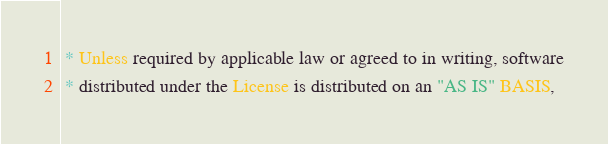<code> <loc_0><loc_0><loc_500><loc_500><_Scala_> * Unless required by applicable law or agreed to in writing, software
 * distributed under the License is distributed on an "AS IS" BASIS,</code> 